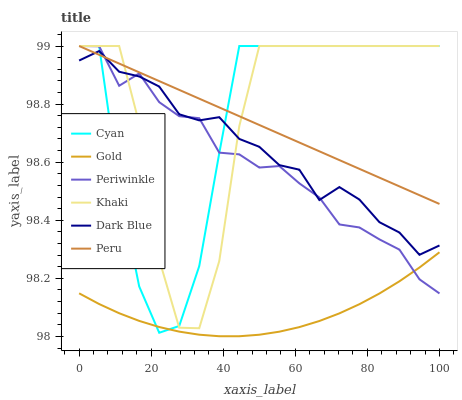Does Gold have the minimum area under the curve?
Answer yes or no. Yes. Does Khaki have the maximum area under the curve?
Answer yes or no. Yes. Does Dark Blue have the minimum area under the curve?
Answer yes or no. No. Does Dark Blue have the maximum area under the curve?
Answer yes or no. No. Is Peru the smoothest?
Answer yes or no. Yes. Is Khaki the roughest?
Answer yes or no. Yes. Is Gold the smoothest?
Answer yes or no. No. Is Gold the roughest?
Answer yes or no. No. Does Gold have the lowest value?
Answer yes or no. Yes. Does Dark Blue have the lowest value?
Answer yes or no. No. Does Cyan have the highest value?
Answer yes or no. Yes. Does Dark Blue have the highest value?
Answer yes or no. No. Is Gold less than Peru?
Answer yes or no. Yes. Is Khaki greater than Gold?
Answer yes or no. Yes. Does Periwinkle intersect Dark Blue?
Answer yes or no. Yes. Is Periwinkle less than Dark Blue?
Answer yes or no. No. Is Periwinkle greater than Dark Blue?
Answer yes or no. No. Does Gold intersect Peru?
Answer yes or no. No. 